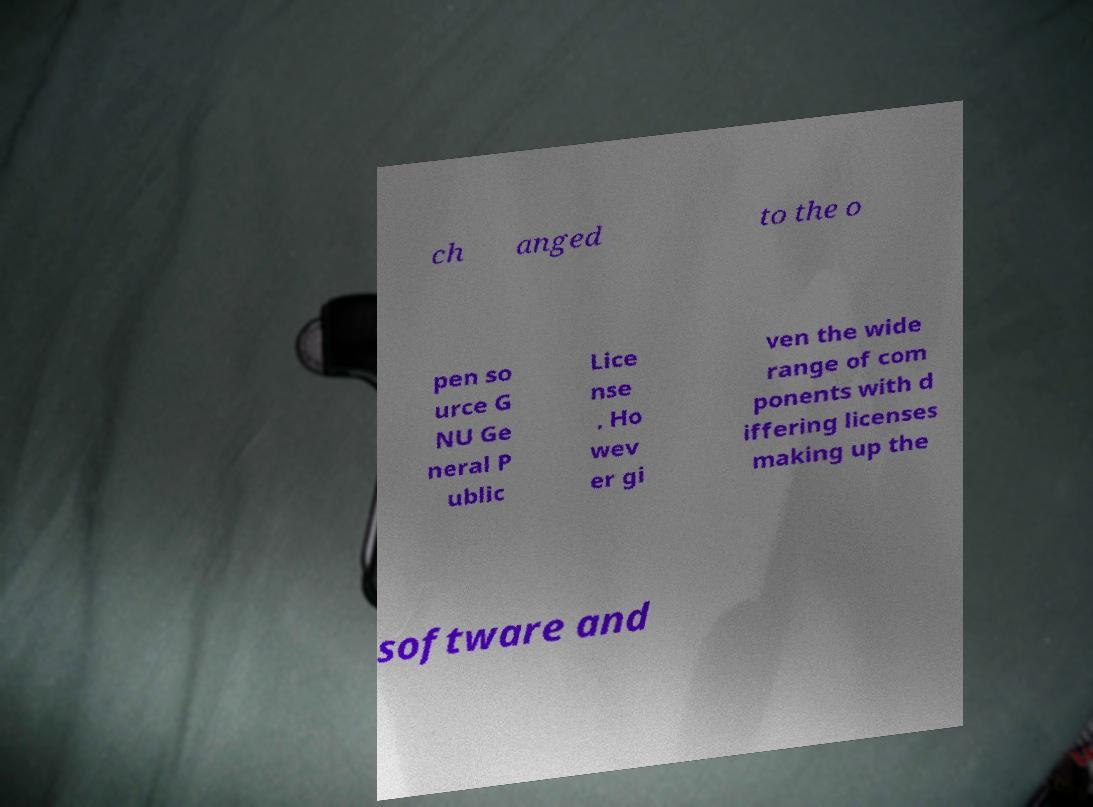For documentation purposes, I need the text within this image transcribed. Could you provide that? ch anged to the o pen so urce G NU Ge neral P ublic Lice nse . Ho wev er gi ven the wide range of com ponents with d iffering licenses making up the software and 